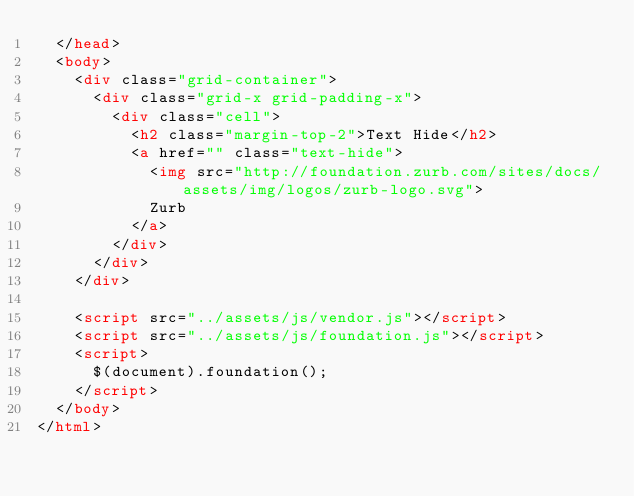<code> <loc_0><loc_0><loc_500><loc_500><_HTML_>  </head>
  <body>
    <div class="grid-container">
      <div class="grid-x grid-padding-x">
        <div class="cell">
          <h2 class="margin-top-2">Text Hide</h2>
          <a href="" class="text-hide">
            <img src="http://foundation.zurb.com/sites/docs/assets/img/logos/zurb-logo.svg">
            Zurb
          </a>
        </div>
      </div>
    </div>

    <script src="../assets/js/vendor.js"></script>
    <script src="../assets/js/foundation.js"></script>
    <script>
      $(document).foundation();
    </script>
  </body>
</html>
</code> 